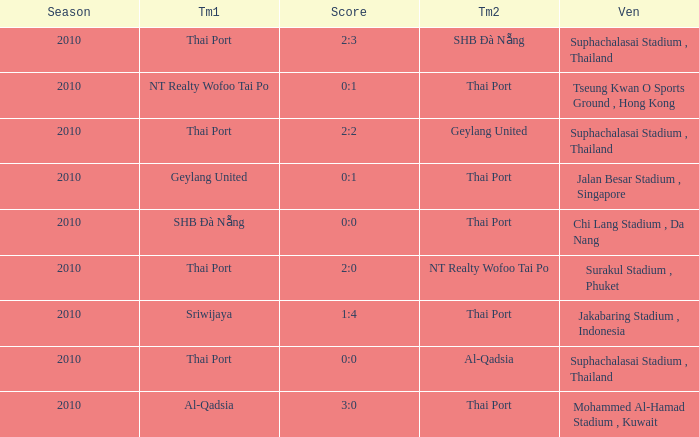What was the score for the game in which Al-Qadsia was Team 2? 0:0. 